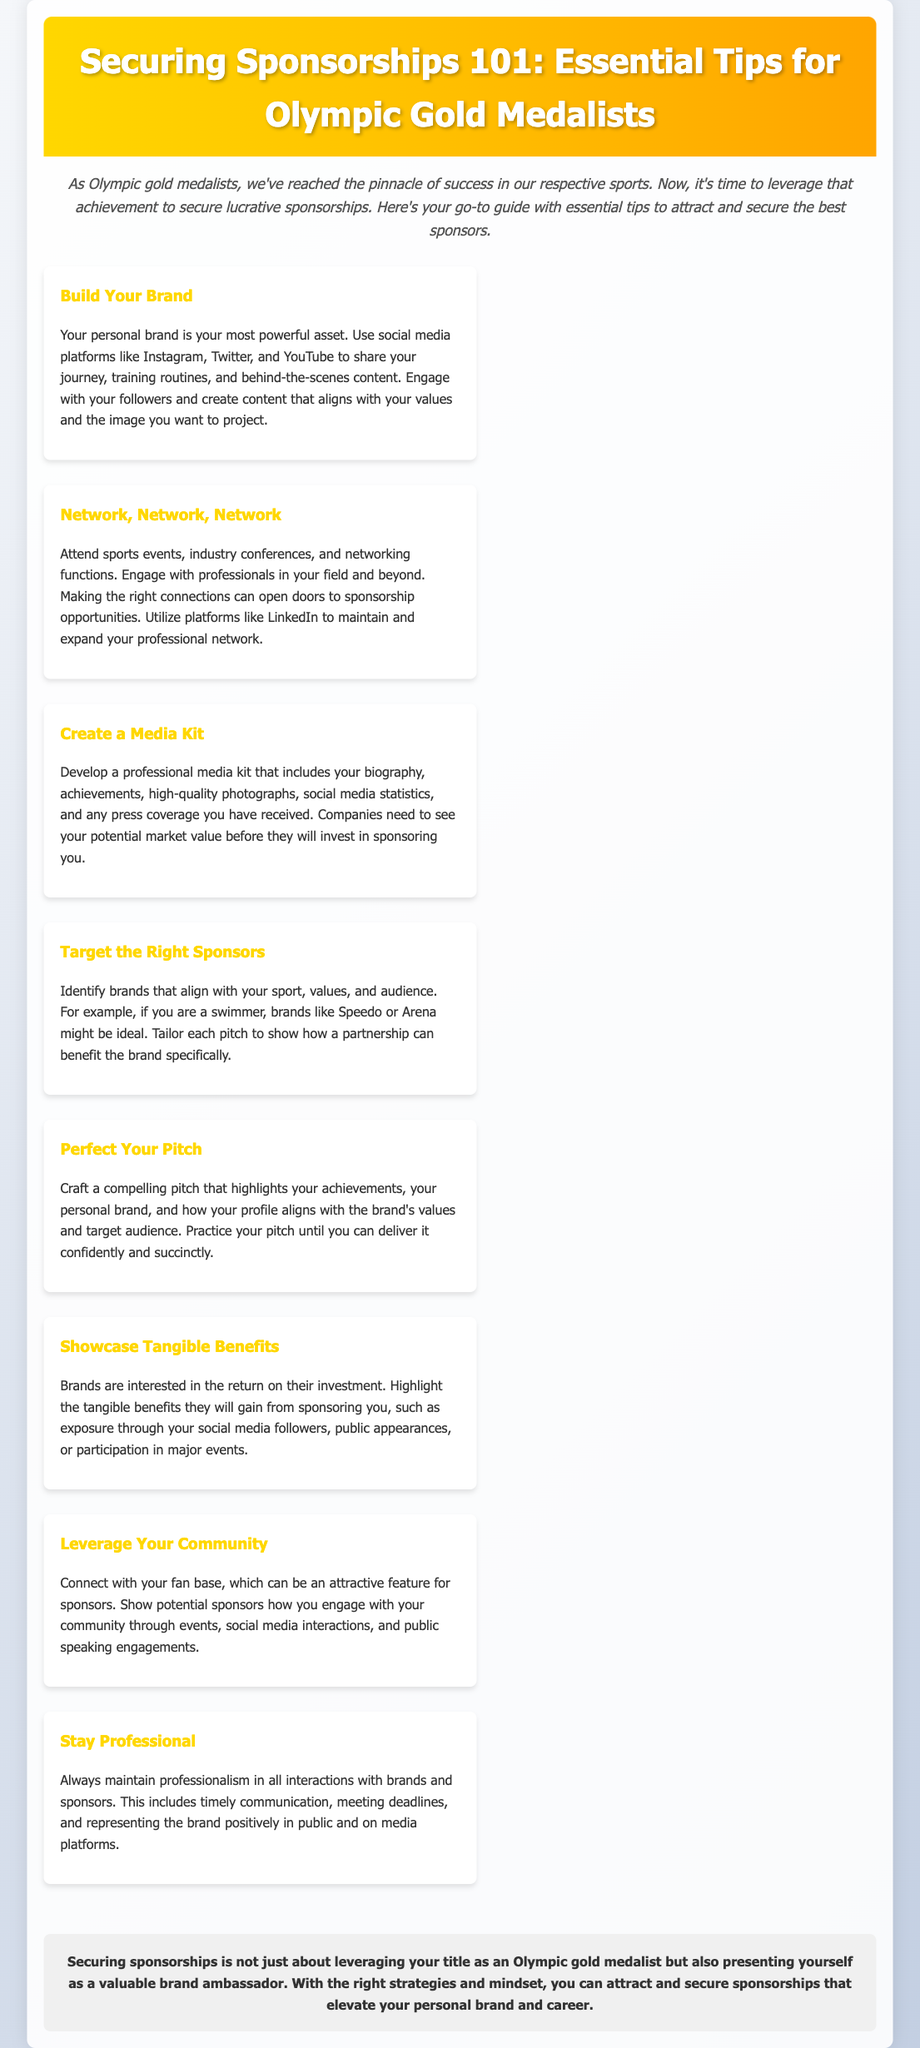What is the title of the document? The title of the document is located in the header section of the HTML.
Answer: Securing Sponsorships 101: Essential Tips for Olympic Gold Medalists How many tips are provided in the document? The document lists a total of eight separate tips for securing sponsorships.
Answer: 8 Which color is used in the header background? The color of the header background is specified in the CSS, which uses a gradient that includes gold and orange.
Answer: Gold and orange What should you develop to attract sponsors according to the tips? The document specifically suggests creating a professional media kit.
Answer: Media kit What is the first tip mentioned in the document? The first tip provided is located at the beginning of the tips section and is clearly highlighted.
Answer: Build Your Brand Which platforms are recommended for building your brand? The recommendation is clearly stated in the tip about building a personal brand.
Answer: Instagram, Twitter, and YouTube What is emphasized as a crucial aspect of maintaining professionalism? The text highlights timely communication as a key element of professionalism.
Answer: Timely communication What should you highlight to showcase tangible benefits to sponsors? The document advises to showcase the return on their investment as a tangible benefit.
Answer: Return on investment 